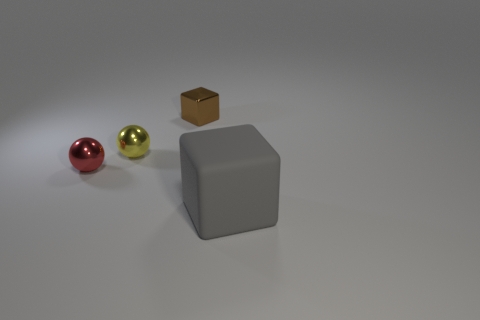Is there anything else that is the same size as the gray cube?
Offer a very short reply. No. Is there any other thing that is the same material as the gray object?
Your answer should be very brief. No. What number of tiny things are left of the metallic object that is behind the tiny sphere that is behind the tiny red shiny object?
Your response must be concise. 2. Do the gray rubber thing and the cube that is on the left side of the matte block have the same size?
Offer a very short reply. No. There is a block that is in front of the block on the left side of the gray rubber thing; how big is it?
Your answer should be compact. Large. What number of other gray objects have the same material as the large thing?
Keep it short and to the point. 0. Are any small shiny objects visible?
Provide a succinct answer. Yes. How big is the ball that is behind the red sphere?
Your answer should be very brief. Small. How many cubes are shiny objects or small brown shiny objects?
Keep it short and to the point. 1. What is the shape of the object that is both in front of the yellow object and on the left side of the big block?
Provide a succinct answer. Sphere. 